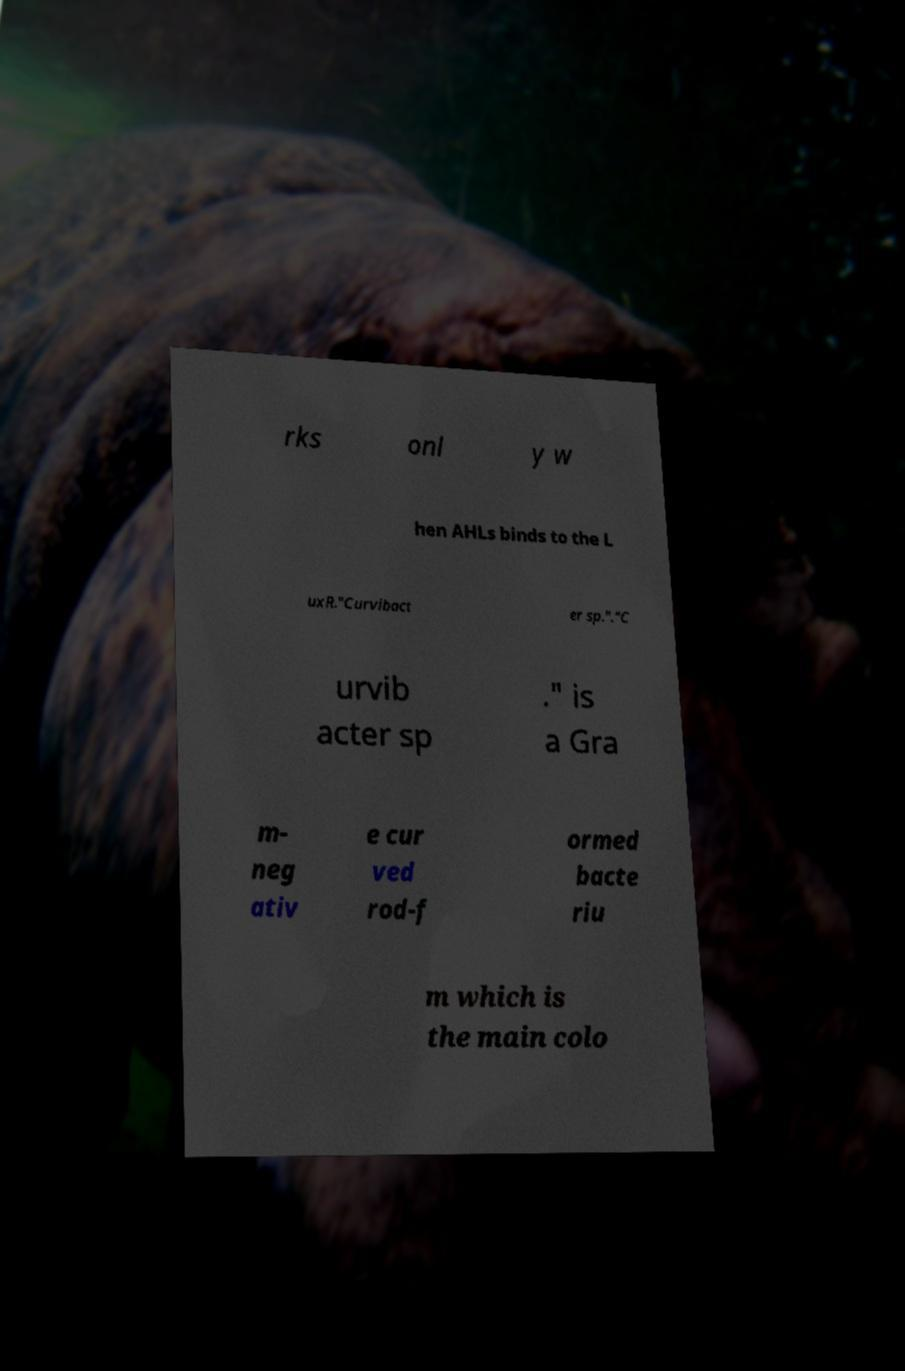Please identify and transcribe the text found in this image. rks onl y w hen AHLs binds to the L uxR."Curvibact er sp."."C urvib acter sp ." is a Gra m- neg ativ e cur ved rod-f ormed bacte riu m which is the main colo 